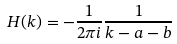<formula> <loc_0><loc_0><loc_500><loc_500>H ( k ) = - \frac { 1 } { 2 \pi i } \frac { 1 } { k - a - b }</formula> 